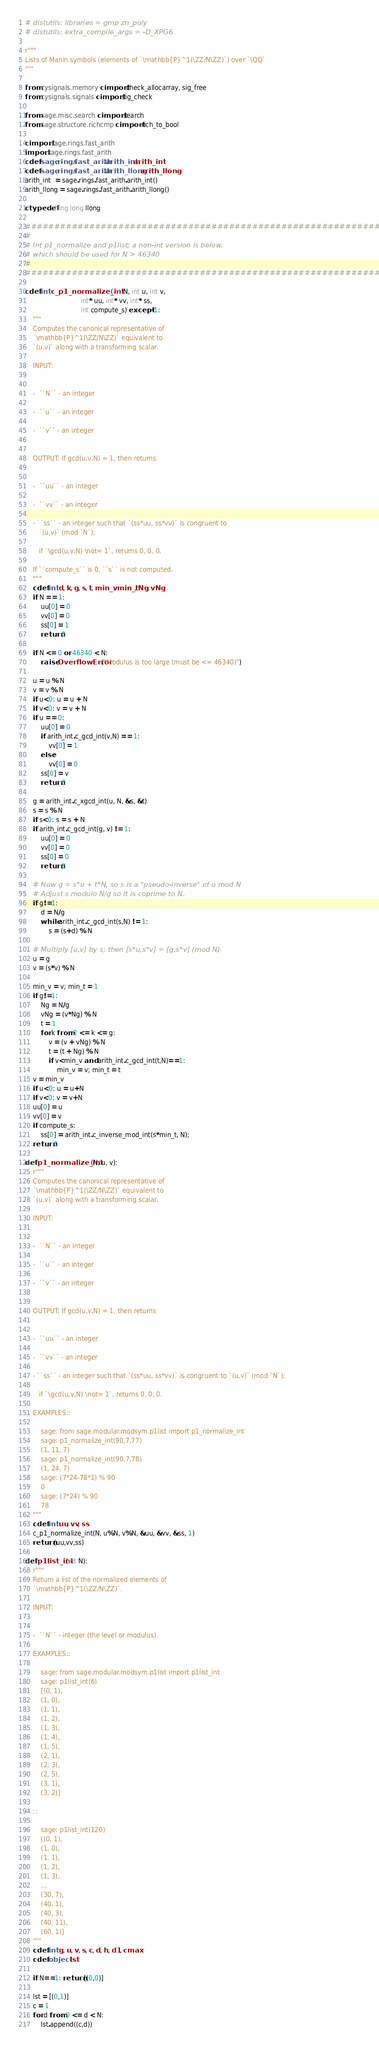<code> <loc_0><loc_0><loc_500><loc_500><_Cython_># distutils: libraries = gmp zn_poly
# distutils: extra_compile_args = -D_XPG6

r"""
Lists of Manin symbols (elements of `\mathbb{P}^1(\ZZ/N\ZZ)`) over `\QQ`
"""

from cysignals.memory cimport check_allocarray, sig_free
from cysignals.signals cimport sig_check

from sage.misc.search cimport search
from sage.structure.richcmp cimport rich_to_bool

cimport sage.rings.fast_arith
import sage.rings.fast_arith
cdef sage.rings.fast_arith.arith_int arith_int
cdef sage.rings.fast_arith.arith_llong arith_llong
arith_int  = sage.rings.fast_arith.arith_int()
arith_llong = sage.rings.fast_arith.arith_llong()

ctypedef long long llong

###############################################################
#
# Int p1_normalize and p1list; a non-int version is below,
# which should be used for N > 46340
#
################################################################

cdef int c_p1_normalize_int(int N, int u, int v,
                            int* uu, int* vv, int* ss,
                            int compute_s) except -1:
    """
    Computes the canonical representative of
    `\mathbb{P}^1(\ZZ/N\ZZ)` equivalent to
    `(u,v)` along with a transforming scalar.

    INPUT:


    -  ``N`` - an integer

    -  ``u`` - an integer

    -  ``v`` - an integer


    OUTPUT: If gcd(u,v,N) = 1, then returns


    -  ``uu`` - an integer

    -  ``vv`` - an integer

    - ``ss`` - an integer such that `(ss*uu, ss*vv)` is congruent to
       `(u,v)` (mod `N`);

       if `\gcd(u,v,N) \not= 1`, returns 0, 0, 0.

    If ``compute_s`` is 0, ``s`` is not computed.
    """
    cdef int d, k, g, s, t, min_v, min_t, Ng, vNg
    if N == 1:
        uu[0] = 0
        vv[0] = 0
        ss[0] = 1
        return 0

    if N <= 0 or 46340 < N:
        raise OverflowError("Modulus is too large (must be <= 46340)")

    u = u % N
    v = v % N
    if u<0: u = u + N
    if v<0: v = v + N
    if u == 0:
        uu[0] = 0
        if arith_int.c_gcd_int(v,N) == 1:
            vv[0] = 1
        else:
            vv[0] = 0
        ss[0] = v
        return 0

    g = arith_int.c_xgcd_int(u, N, &s, &t)
    s = s % N
    if s<0: s = s + N
    if arith_int.c_gcd_int(g, v) != 1:
        uu[0] = 0
        vv[0] = 0
        ss[0] = 0
        return 0

    # Now g = s*u + t*N, so s is a "pseudo-inverse" of u mod N
    # Adjust s modulo N/g so it is coprime to N.
    if g!=1:
        d = N/g
        while arith_int.c_gcd_int(s,N) != 1:
            s = (s+d) % N

    # Multiply [u,v] by s; then [s*u,s*v] = [g,s*v] (mod N)
    u = g
    v = (s*v) % N

    min_v = v; min_t = 1
    if g!=1:
        Ng = N/g
        vNg = (v*Ng) % N
        t = 1
        for k from 2 <= k <= g:
            v = (v + vNg) % N
            t = (t + Ng) % N
            if v<min_v and arith_int.c_gcd_int(t,N)==1:
                min_v = v; min_t = t
    v = min_v
    if u<0: u = u+N
    if v<0: v = v+N
    uu[0] = u
    vv[0] = v
    if compute_s:
        ss[0] = arith_int.c_inverse_mod_int(s*min_t, N);
    return 0

def p1_normalize_int(N, u, v):
    r"""
    Computes the canonical representative of
    `\mathbb{P}^1(\ZZ/N\ZZ)` equivalent to
    `(u,v)` along with a transforming scalar.

    INPUT:


    -  ``N`` - an integer

    -  ``u`` - an integer

    -  ``v`` - an integer


    OUTPUT: If gcd(u,v,N) = 1, then returns


    -  ``uu`` - an integer

    -  ``vv`` - an integer

    - ``ss`` - an integer such that `(ss*uu, ss*vv)` is congruent to `(u,v)` (mod `N`);

       if `\gcd(u,v,N) \not= 1`, returns 0, 0, 0.

    EXAMPLES::

        sage: from sage.modular.modsym.p1list import p1_normalize_int
        sage: p1_normalize_int(90,7,77)
        (1, 11, 7)
        sage: p1_normalize_int(90,7,78)
        (1, 24, 7)
        sage: (7*24-78*1) % 90
        0
        sage: (7*24) % 90
        78
    """
    cdef int uu, vv, ss
    c_p1_normalize_int(N, u%N, v%N, &uu, &vv, &ss, 1)
    return (uu,vv,ss)

def p1list_int(int N):
    r"""
    Return a list of the normalized elements of
    `\mathbb{P}^1(\ZZ/N\ZZ)`.

    INPUT:


    -  ``N`` - integer (the level or modulus).

    EXAMPLES::

        sage: from sage.modular.modsym.p1list import p1list_int
        sage: p1list_int(6)
        [(0, 1),
        (1, 0),
        (1, 1),
        (1, 2),
        (1, 3),
        (1, 4),
        (1, 5),
        (2, 1),
        (2, 3),
        (2, 5),
        (3, 1),
        (3, 2)]

    ::

        sage: p1list_int(120)
        [(0, 1),
        (1, 0),
        (1, 1),
        (1, 2),
        (1, 3),
        ...
        (30, 7),
        (40, 1),
        (40, 3),
        (40, 11),
        (60, 1)]
    """
    cdef int g, u, v, s, c, d, h, d1, cmax
    cdef object lst

    if N==1: return [(0,0)]

    lst = [(0,1)]
    c = 1
    for d from 0 <= d < N:
        lst.append((c,d))
</code> 